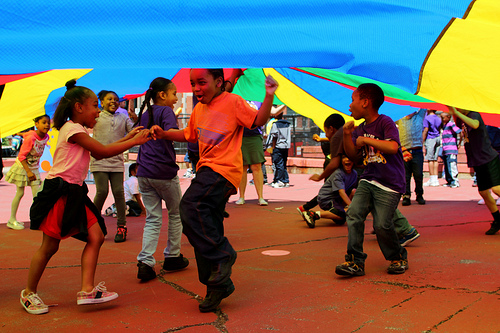<image>
Is there a boy under the large sheet? No. The boy is not positioned under the large sheet. The vertical relationship between these objects is different. Is there a kid in front of the parachute? No. The kid is not in front of the parachute. The spatial positioning shows a different relationship between these objects. 